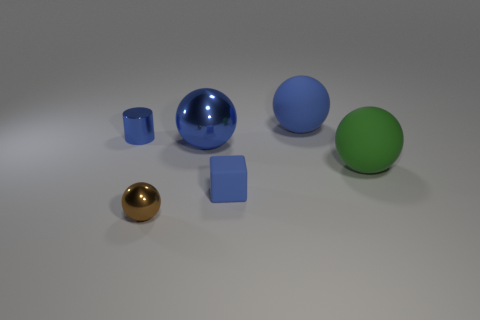Add 1 tiny yellow balls. How many objects exist? 7 Subtract all balls. How many objects are left? 2 Add 2 blue blocks. How many blue blocks exist? 3 Subtract 0 red spheres. How many objects are left? 6 Subtract all blocks. Subtract all big matte spheres. How many objects are left? 3 Add 6 metal objects. How many metal objects are left? 9 